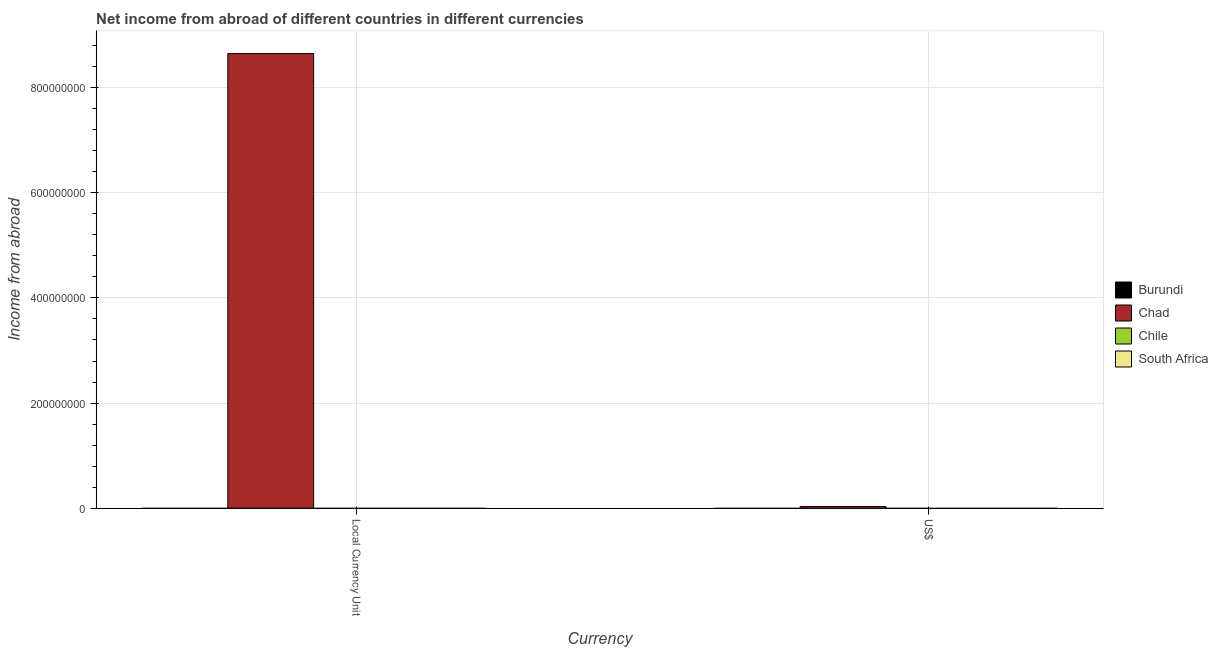Are the number of bars per tick equal to the number of legend labels?
Give a very brief answer. No. What is the label of the 1st group of bars from the left?
Offer a very short reply. Local Currency Unit. What is the income from abroad in constant 2005 us$ in Chile?
Offer a very short reply. 0. Across all countries, what is the maximum income from abroad in us$?
Keep it short and to the point. 3.13e+06. Across all countries, what is the minimum income from abroad in constant 2005 us$?
Your answer should be very brief. 0. In which country was the income from abroad in constant 2005 us$ maximum?
Your answer should be very brief. Chad. What is the total income from abroad in us$ in the graph?
Offer a very short reply. 3.13e+06. What is the average income from abroad in us$ per country?
Your response must be concise. 7.82e+05. What is the difference between the income from abroad in us$ and income from abroad in constant 2005 us$ in Chad?
Your answer should be compact. -8.62e+08. In how many countries, is the income from abroad in constant 2005 us$ greater than 440000000 units?
Your response must be concise. 1. In how many countries, is the income from abroad in us$ greater than the average income from abroad in us$ taken over all countries?
Keep it short and to the point. 1. How many bars are there?
Offer a terse response. 2. Are all the bars in the graph horizontal?
Offer a terse response. No. Are the values on the major ticks of Y-axis written in scientific E-notation?
Offer a very short reply. No. Does the graph contain any zero values?
Ensure brevity in your answer.  Yes. Where does the legend appear in the graph?
Ensure brevity in your answer.  Center right. How many legend labels are there?
Offer a very short reply. 4. What is the title of the graph?
Your answer should be compact. Net income from abroad of different countries in different currencies. Does "Turks and Caicos Islands" appear as one of the legend labels in the graph?
Your answer should be very brief. No. What is the label or title of the X-axis?
Keep it short and to the point. Currency. What is the label or title of the Y-axis?
Offer a terse response. Income from abroad. What is the Income from abroad in Burundi in Local Currency Unit?
Offer a very short reply. 0. What is the Income from abroad in Chad in Local Currency Unit?
Keep it short and to the point. 8.65e+08. What is the Income from abroad in Chile in Local Currency Unit?
Give a very brief answer. 0. What is the Income from abroad in South Africa in Local Currency Unit?
Your response must be concise. 0. What is the Income from abroad of Burundi in US$?
Make the answer very short. 0. What is the Income from abroad in Chad in US$?
Offer a very short reply. 3.13e+06. Across all Currency, what is the maximum Income from abroad in Chad?
Offer a terse response. 8.65e+08. Across all Currency, what is the minimum Income from abroad in Chad?
Offer a terse response. 3.13e+06. What is the total Income from abroad in Chad in the graph?
Your answer should be compact. 8.68e+08. What is the total Income from abroad in Chile in the graph?
Provide a succinct answer. 0. What is the difference between the Income from abroad of Chad in Local Currency Unit and that in US$?
Keep it short and to the point. 8.62e+08. What is the average Income from abroad of Chad per Currency?
Ensure brevity in your answer.  4.34e+08. What is the average Income from abroad of South Africa per Currency?
Offer a very short reply. 0. What is the ratio of the Income from abroad in Chad in Local Currency Unit to that in US$?
Make the answer very short. 276.4. What is the difference between the highest and the second highest Income from abroad in Chad?
Provide a short and direct response. 8.62e+08. What is the difference between the highest and the lowest Income from abroad in Chad?
Keep it short and to the point. 8.62e+08. 